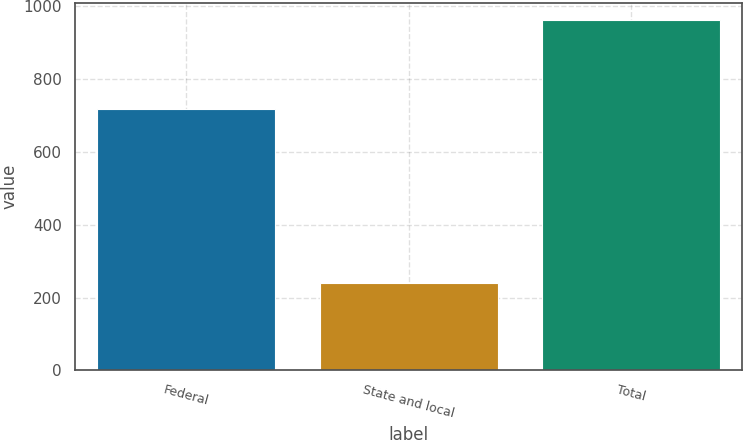Convert chart to OTSL. <chart><loc_0><loc_0><loc_500><loc_500><bar_chart><fcel>Federal<fcel>State and local<fcel>Total<nl><fcel>717<fcel>239<fcel>962<nl></chart> 